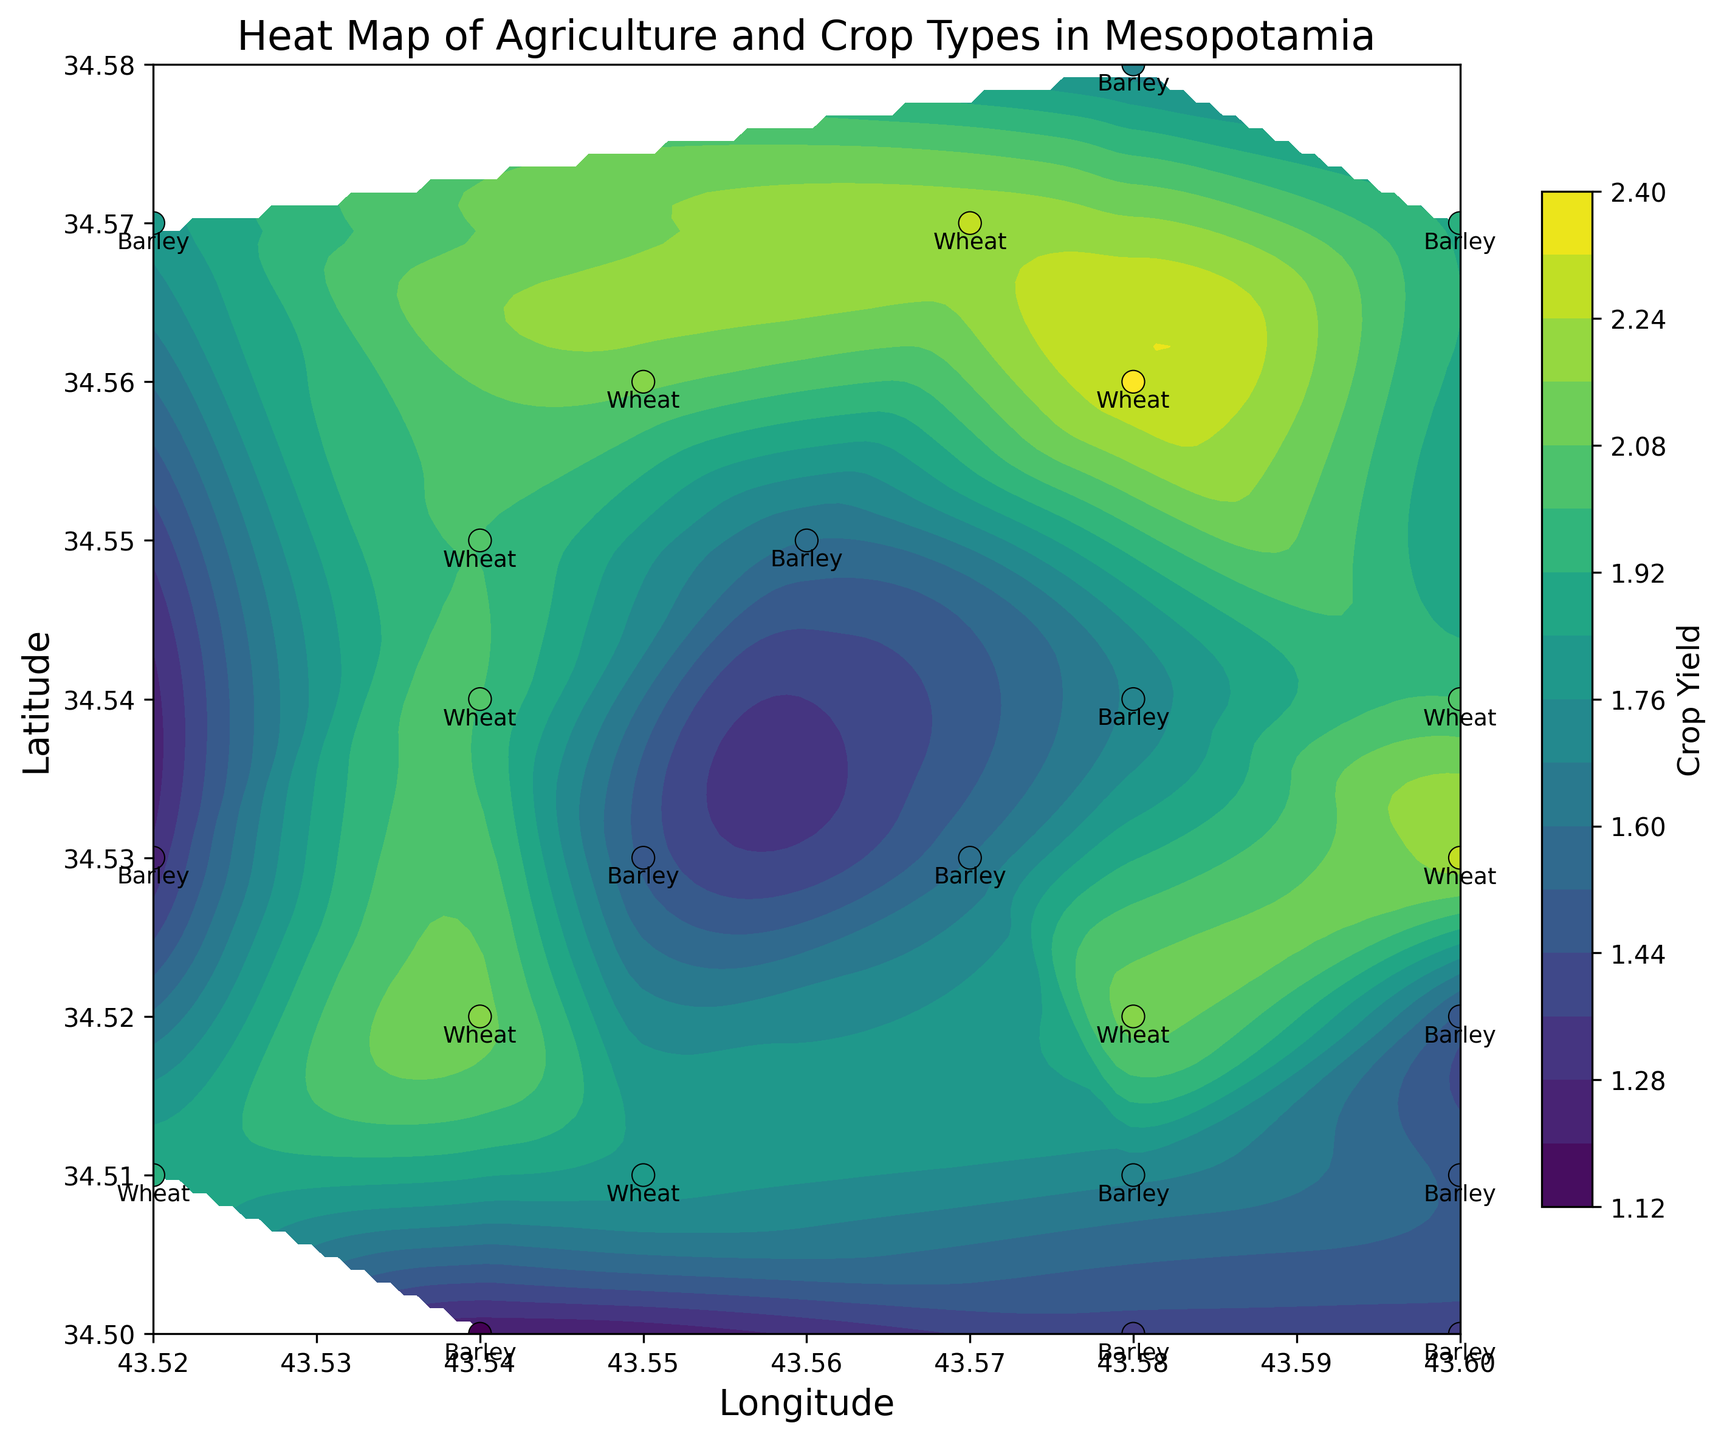What is the average yield of Barley crops in Mesopotamia based on the figure? Identify all data points representing Barley crops and sum their yields (1.5, 1.7, 1.4, 1.6, 1.3, 1.7, 1.5, 1.4, 1.8, 1.9, 1.2). The total yield is 17.0, and the number of data points is 11. So, the average yield is 17.0/11 ≈ 1.55
Answer: 1.55 Which crop type is predominantly found at the location with the highest yield? The figure shows that the highest yield contour is labeled near the coordinates approximately (34.560, 43.580). Barley and Wheat are present, but Wheat shows higher yields around these coordinates (~2.3). Thus, Wheat is predominant at the highest yield location.
Answer: Wheat How does the yield distribution compare between Barley and Wheat crops? Barley yields range from 1.2 to 1.9, while Wheat yields range from 1.8 to 2.3. Overlaying the scatter plot with contour visuals, Wheat generally lies in areas with higher yield contours (darker greens). Hence, Wheat has a higher average yield compared to Barley.
Answer: Wheat has higher yields What is the yield at the location (34.530, 43.570) and which crop is grown there? Locate the coordinates (34.530, 43.570) on the scatter plot. The data point is annotated with Barley and a yield of 1.6.
Answer: Barley with 1.6 yield Are there any specific regions where a single crop type dominates the yield distribution? By observing the contour map, areas around (34.540, 43.540) to (34.570, 43.580) show dense Wheat yields, indicated by higher values and annotations. Similar observation with Barley's presence northward (34.520, 43.600) to (34.530, 43.570).
Answer: Yes What is the range of yields observed for Wheat crops? Looking at the contour map, the Wheat crop annotations show yields ranging from 1.8 to 2.3 at various annotated locations (e.g., 34.520, 43.600 and 34.540, 43.580).
Answer: 1.8 to 2.3 Is there any observable pattern or gradient in crop yield distribution from west to east? The contour lines indicate a generally eastward increase in yields, with higher isopleths or yield values (~2.2 - 2.3) more concentrated towards the right (East). This suggests an increasing yield gradient or pattern in that direction.
Answer: Increasing towards East What is the difference in yield between the crops at (34.520, 43.540) and (34.500, 43.540)? Locate the coordinates (34.520, 43.540) and (34.500, 43.540). Wheat at (34.520, 43.540) has a yield of 2.1; Barley at (34.500, 43.540) has a yield of 1.2. The difference is 2.1 - 1.2 = 0.9.
Answer: 0.9 Between coordinates (34.510, 43.520) and (34.570, 43.600), which one has the highest yield and for which crop? Yield at (34.510, 43.520) is 1.9 for Wheat, and yield at (34.570, 43.600) is 1.9 for Barley. Both yields are equal.
Answer: Both are equal at 1.9 